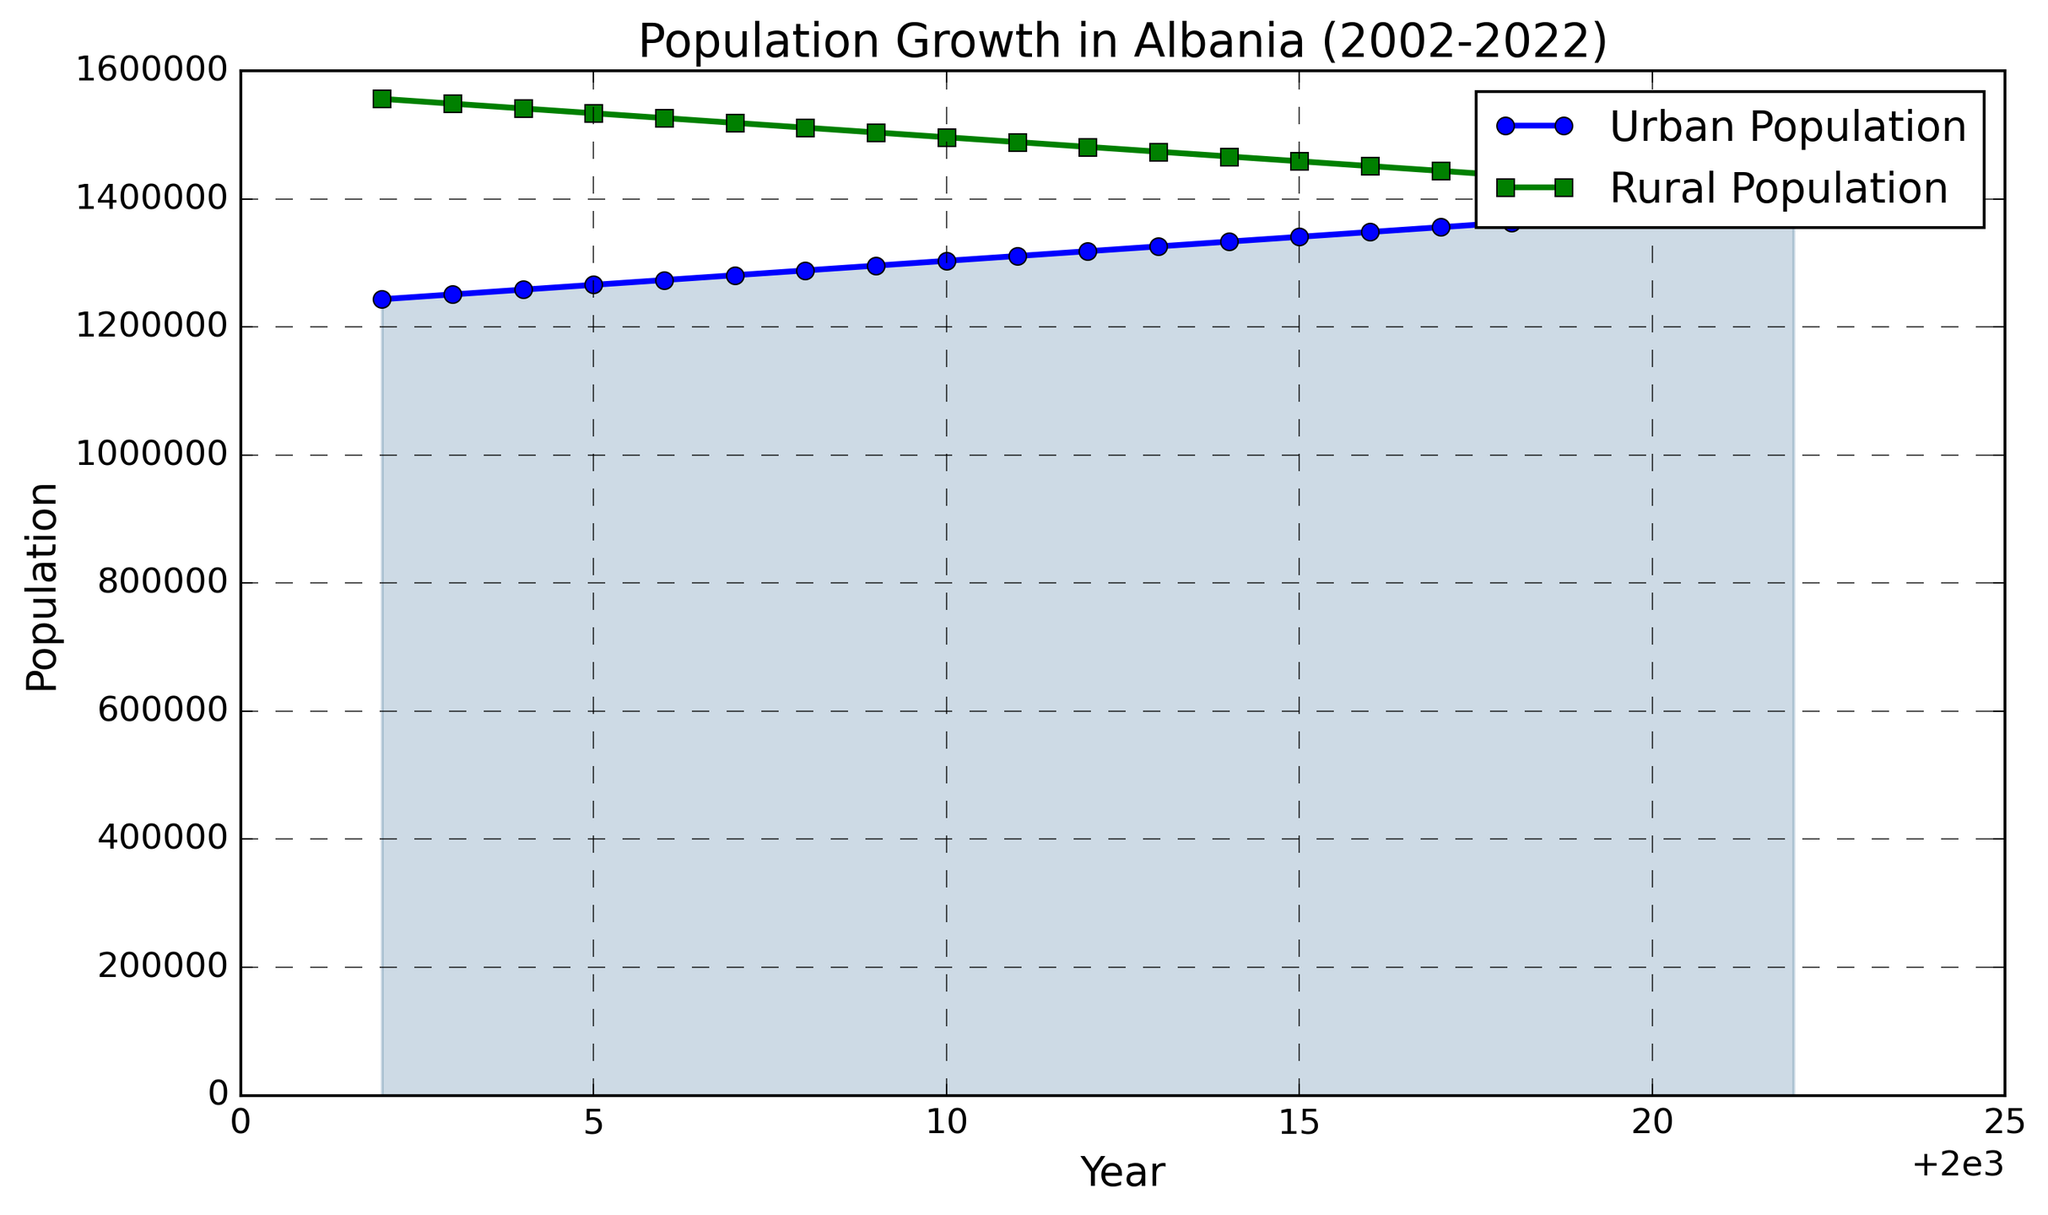What is the population trend in urban areas over the past twenty years? From 2002 to 2022, the line representing the urban population shows a consistent upward trend with gradual increases each year. Hence, the population in urban areas has steadily increased.
Answer: Steadily increasing What is the difference in population between urban and rural areas in 2002 compared to 2022? In 2002, the urban population is 1,243,500, and the rural population is 1,556,500. The difference in 2002 is 1,556,500 - 1,243,500 = 313,000. In 2022, the urban population is 1,393,500, and the rural population is 1,406,500. The difference in 2022 is 1,406,500 - 1,393,500 = 13,000.
Answer: 300,000 (decrease) Which year marks the first time the rural population falls below the urban population? To find this, identify the point where the green (rural) line first falls below the blue (urban) line. This occurs in 2012.
Answer: 2012 What is the average population growth per year in urban areas from 2002 to 2022? The urban population in 2022 is 1,393,500, and in 2002 it was 1,243,500. The total growth is 1,393,500 - 1,243,500 = 150,000. Over 20 years, the average growth per year is 150,000 / 20 = 7,500.
Answer: 7,500 Comparing the fill between the rural and urban lines, which area has a larger shaded area, and what does this indicate? Visually, the area filled under the green (rural) line is initially larger, but over time, the area under the blue (urban) line becomes more significant. This indicates the rural population is decreasing while the urban population is increasing over time.
Answer: Urban area by 2022 In which year did the urban population reach approximately 1.3 million? The blue (urban) line reaches around 1,300,000 around 2010.
Answer: 2010 Is there any year where the urban or rural population remained constant from the previous year? By examining the lines, there is no noticeable flat segment indicating population constancy; therefore, there is no year where the population remained constant from the previous year.
Answer: No What is the overall trend observed for the rural population from 2002 to 2022? From 2002 to 2022, the green (rural) line shows a consistent downward trend, indicating that the rural population has steadily decreased.
Answer: Steadily decreasing 